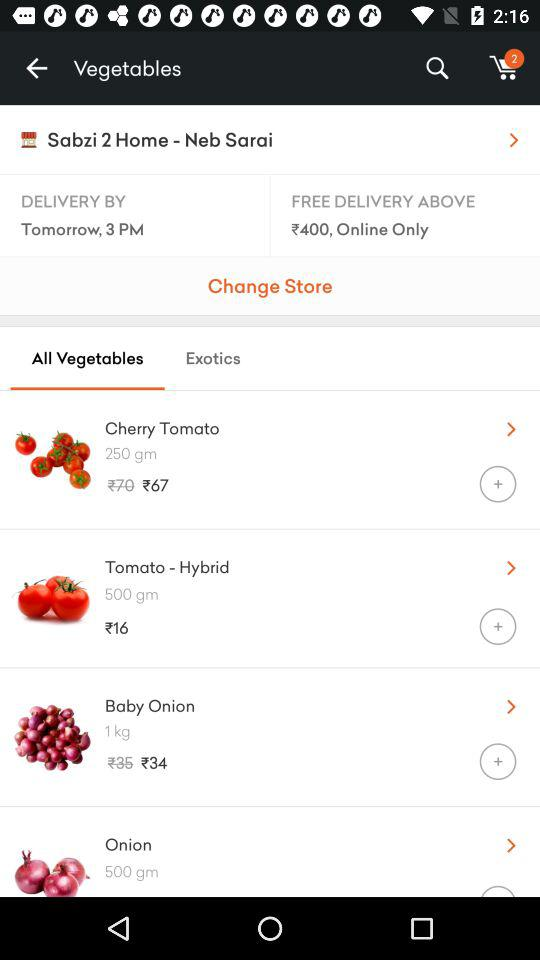How much is the minimum order value to get free delivery? The minimum order value to get free delivery is ₹400. 